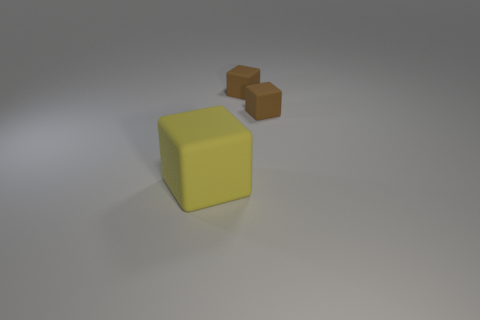Add 3 big red spheres. How many objects exist? 6 Subtract 0 yellow cylinders. How many objects are left? 3 Subtract all large cubes. Subtract all big matte cubes. How many objects are left? 1 Add 3 tiny rubber objects. How many tiny rubber objects are left? 5 Add 1 big blocks. How many big blocks exist? 2 